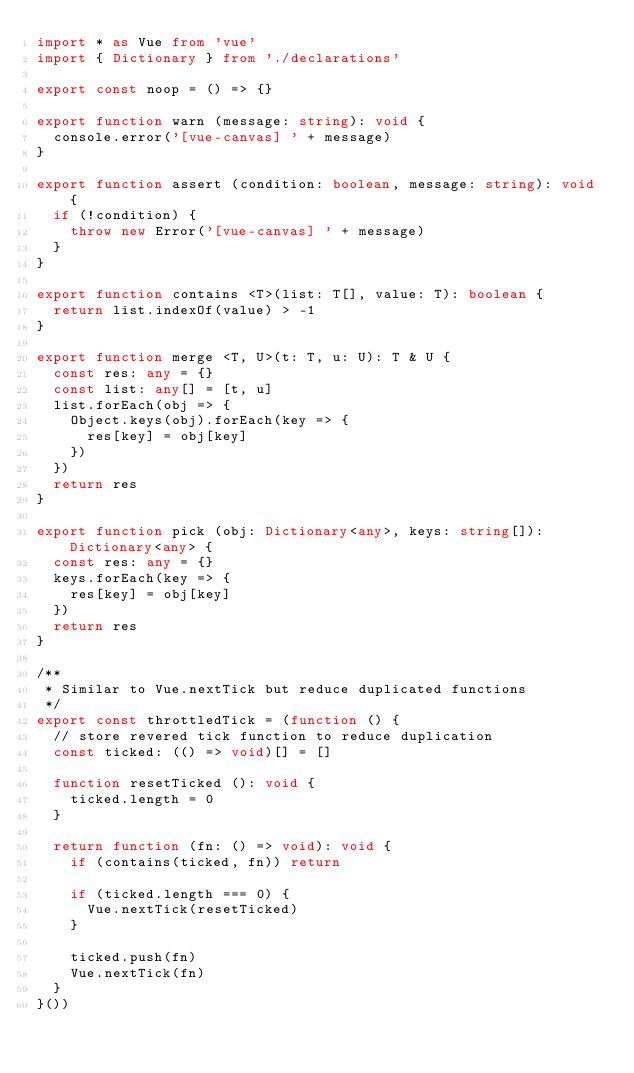<code> <loc_0><loc_0><loc_500><loc_500><_TypeScript_>import * as Vue from 'vue'
import { Dictionary } from './declarations'

export const noop = () => {}

export function warn (message: string): void {
  console.error('[vue-canvas] ' + message)
}

export function assert (condition: boolean, message: string): void {
  if (!condition) {
    throw new Error('[vue-canvas] ' + message)
  }
}

export function contains <T>(list: T[], value: T): boolean {
  return list.indexOf(value) > -1
}

export function merge <T, U>(t: T, u: U): T & U {
  const res: any = {}
  const list: any[] = [t, u]
  list.forEach(obj => {
    Object.keys(obj).forEach(key => {
      res[key] = obj[key]
    })
  })
  return res
}

export function pick (obj: Dictionary<any>, keys: string[]): Dictionary<any> {
  const res: any = {}
  keys.forEach(key => {
    res[key] = obj[key]
  })
  return res
}

/**
 * Similar to Vue.nextTick but reduce duplicated functions
 */
export const throttledTick = (function () {
  // store revered tick function to reduce duplication
  const ticked: (() => void)[] = []

  function resetTicked (): void {
    ticked.length = 0
  }

  return function (fn: () => void): void {
    if (contains(ticked, fn)) return

    if (ticked.length === 0) {
      Vue.nextTick(resetTicked)
    }

    ticked.push(fn)
    Vue.nextTick(fn)
  }
}())
</code> 